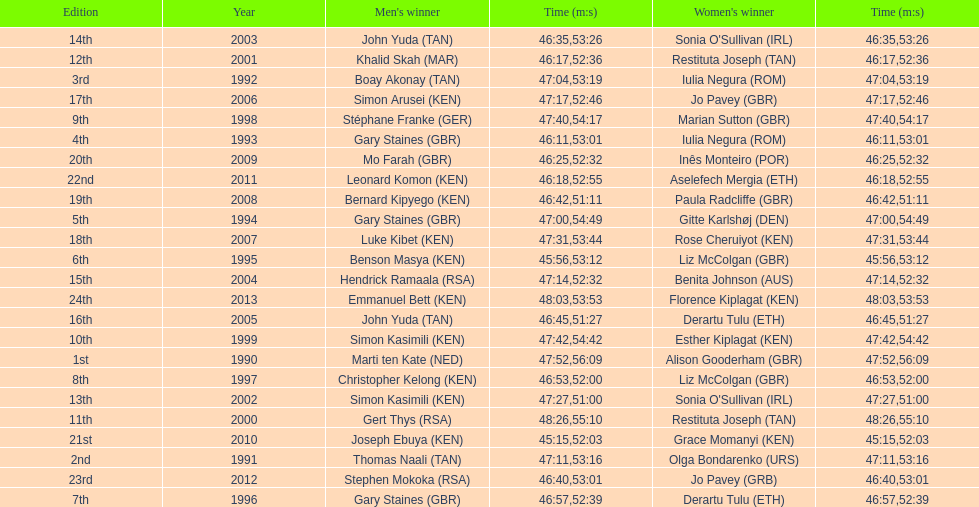What is the difference in finishing times for the men's and women's bupa great south run finish for 2013? 5:50. 